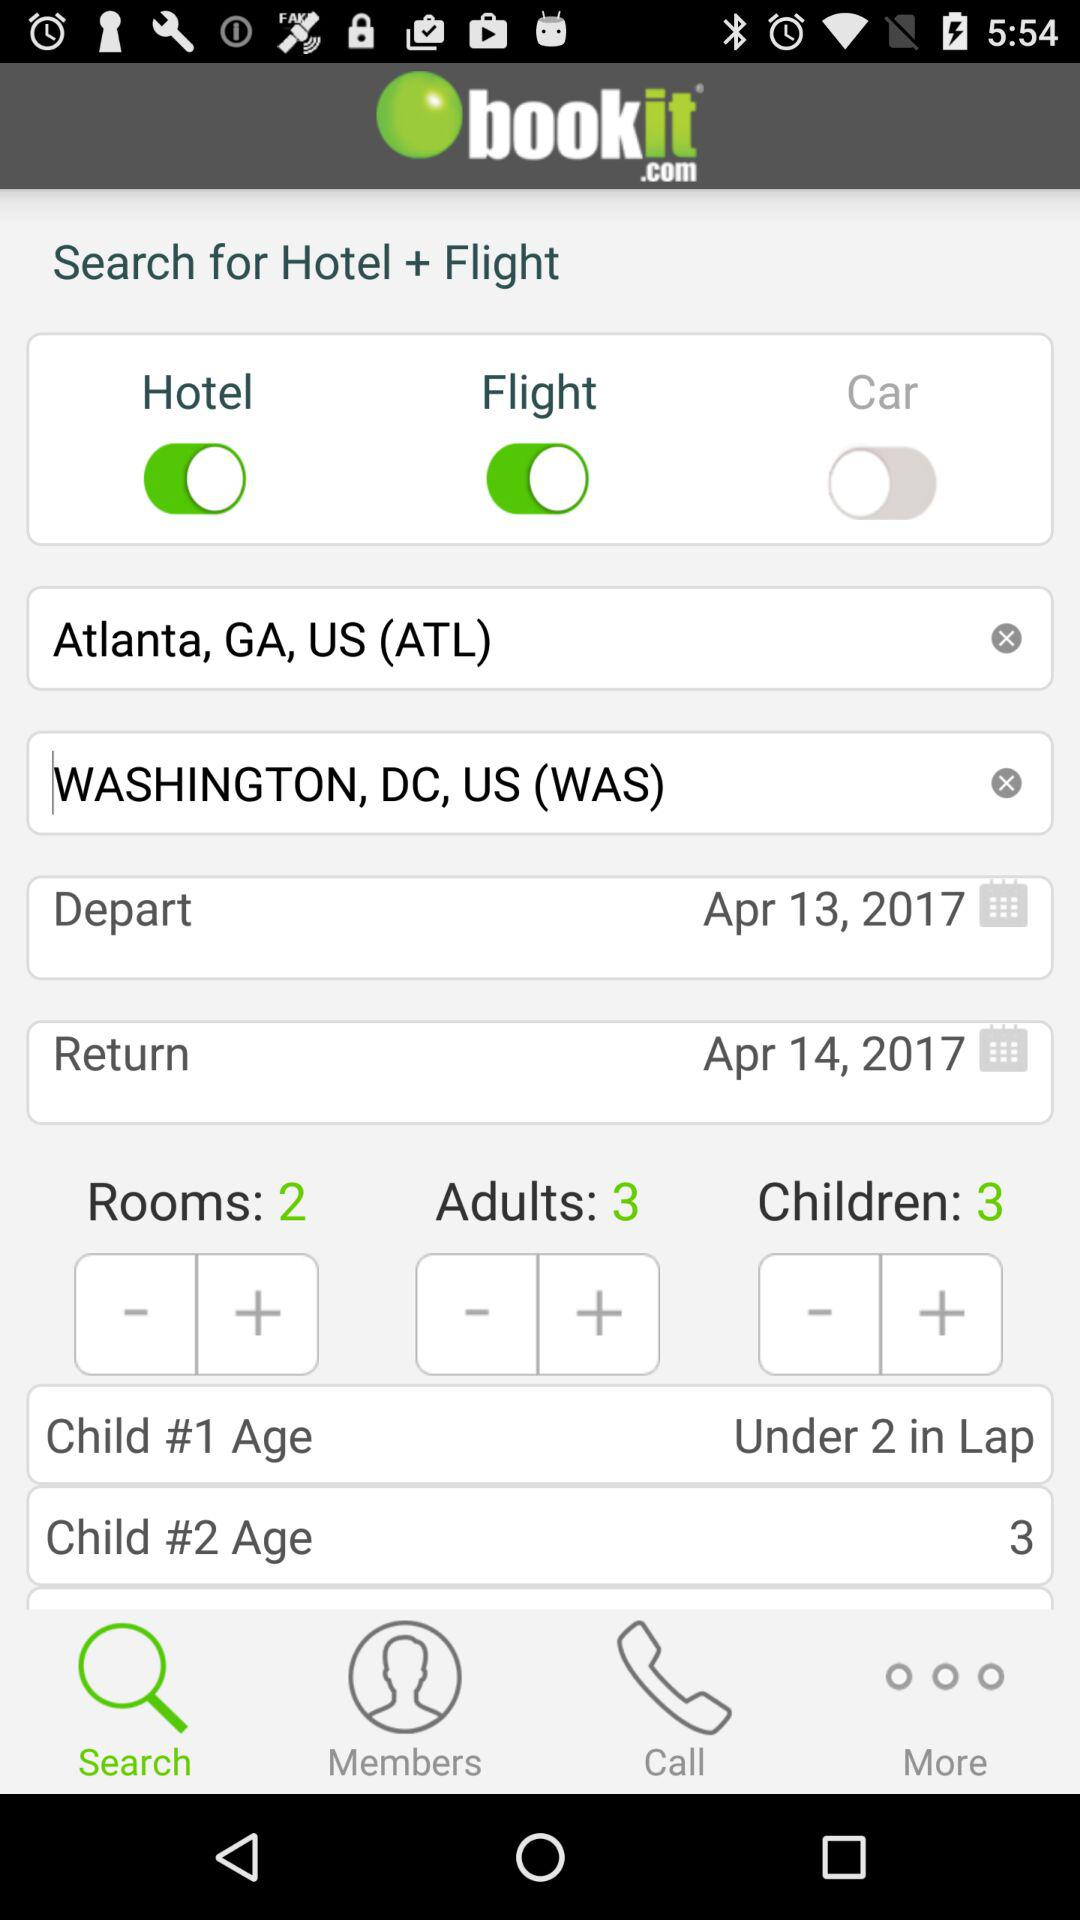How many destinations are selected?
Answer the question using a single word or phrase. 2 